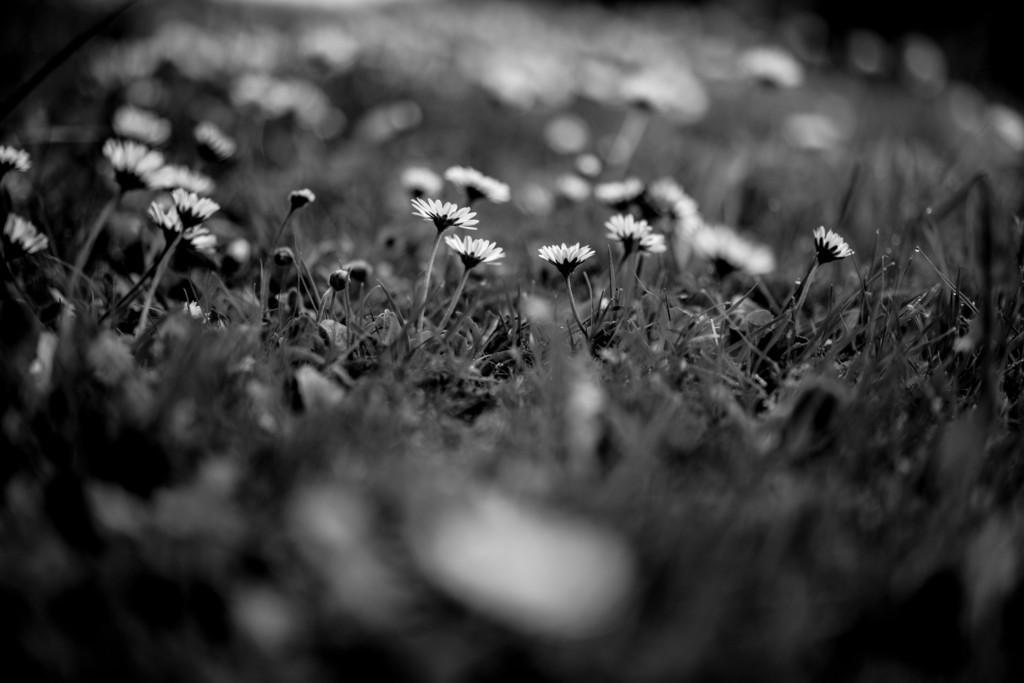What is the color scheme of the photography in the image? The photography is in black and white. What is the main subject of the image? The main subject of the image is a grass plant surface. What additional elements can be seen in the image? There are flowers and flower buds visible in the image. What type of vegetable is being played on the drum in the image? There is no vegetable or drum present in the image; it features a grass plant surface with flowers and flower buds. How many teeth can be seen in the image? There are no teeth visible in the image. 